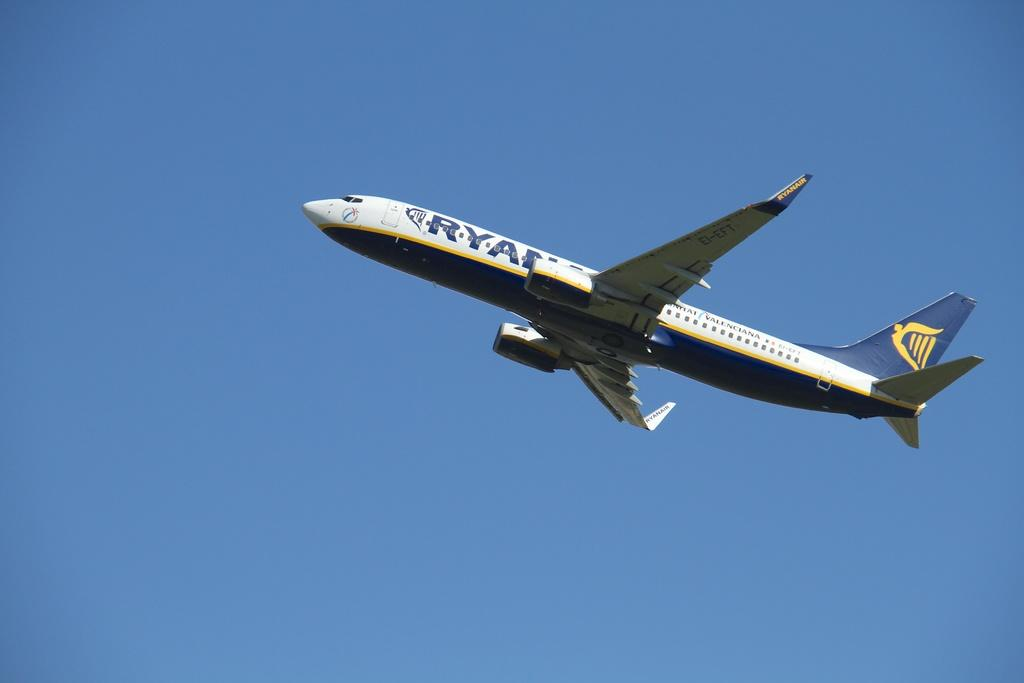What is the main subject of the image? The main subject of the image is an airplane. Where is the airplane located in the image? The airplane is in the center of the image. What can be seen in the background of the image? There is sky visible in the background of the image. What idea does the girl in the image have about the airplane? There is no girl present in the image, so it is not possible to determine any ideas she might have about the airplane. 